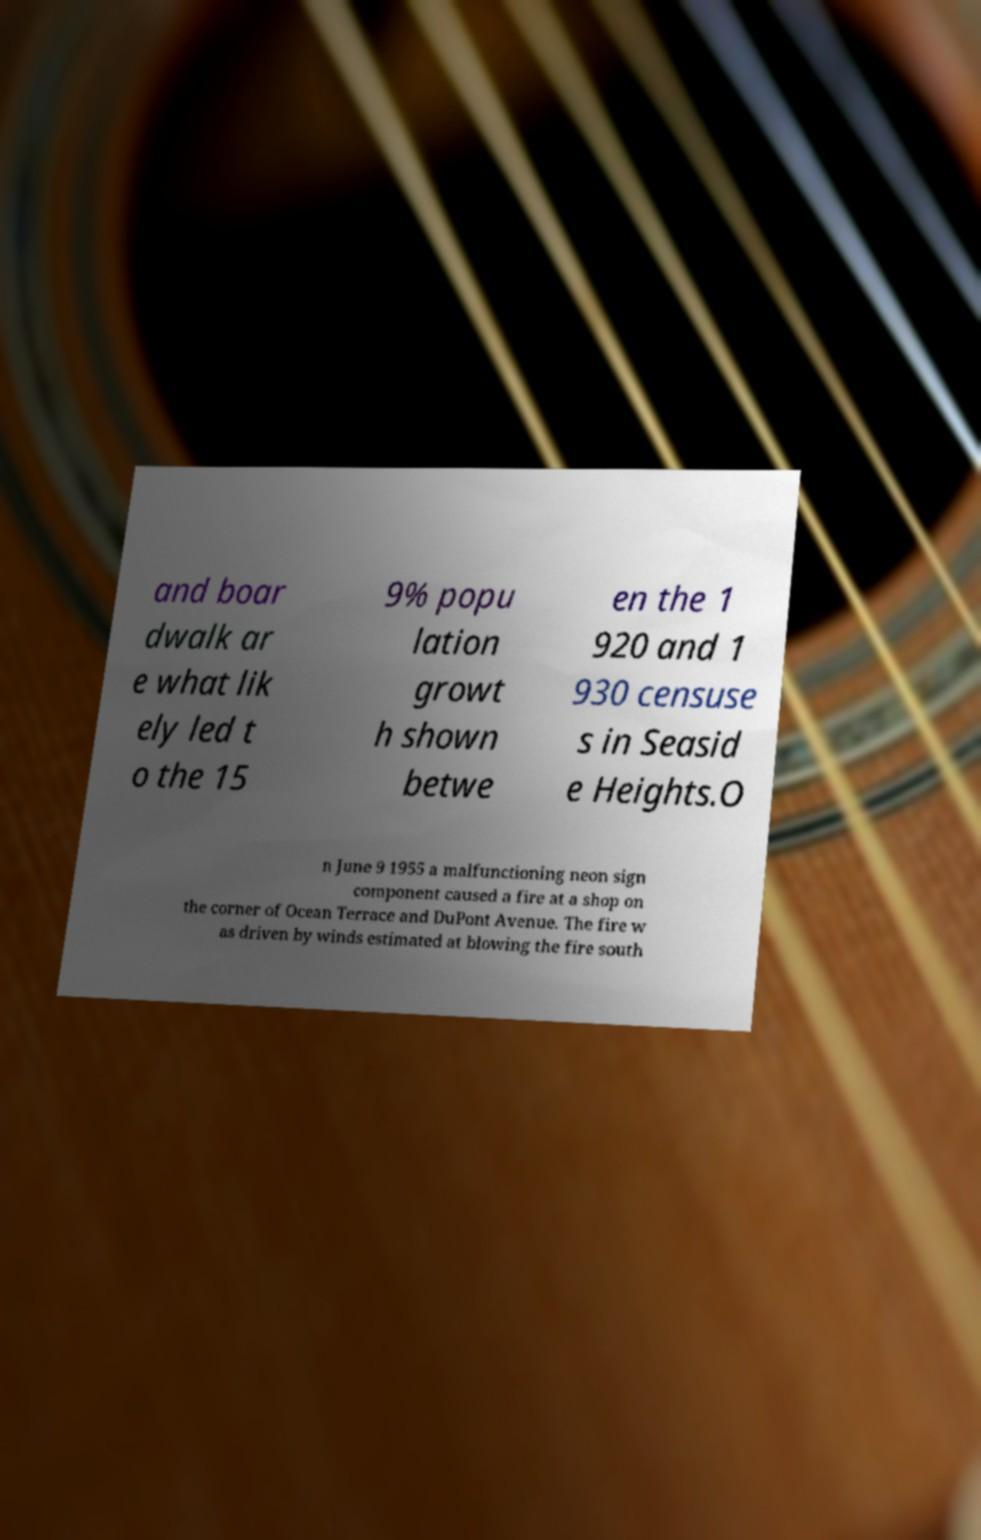For documentation purposes, I need the text within this image transcribed. Could you provide that? and boar dwalk ar e what lik ely led t o the 15 9% popu lation growt h shown betwe en the 1 920 and 1 930 censuse s in Seasid e Heights.O n June 9 1955 a malfunctioning neon sign component caused a fire at a shop on the corner of Ocean Terrace and DuPont Avenue. The fire w as driven by winds estimated at blowing the fire south 